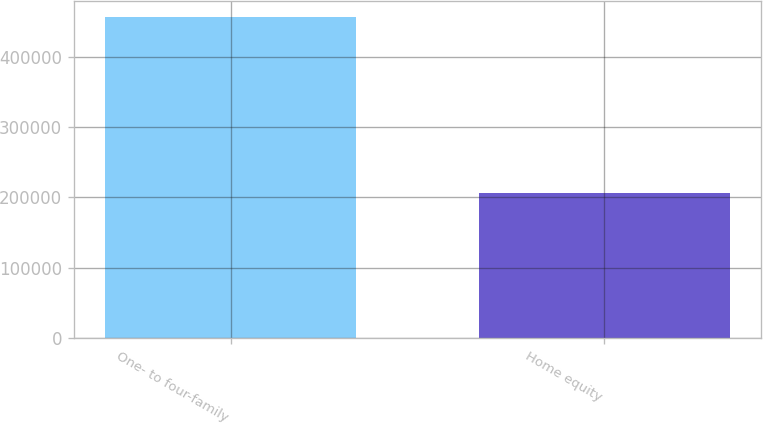Convert chart to OTSL. <chart><loc_0><loc_0><loc_500><loc_500><bar_chart><fcel>One- to four-family<fcel>Home equity<nl><fcel>456109<fcel>205879<nl></chart> 